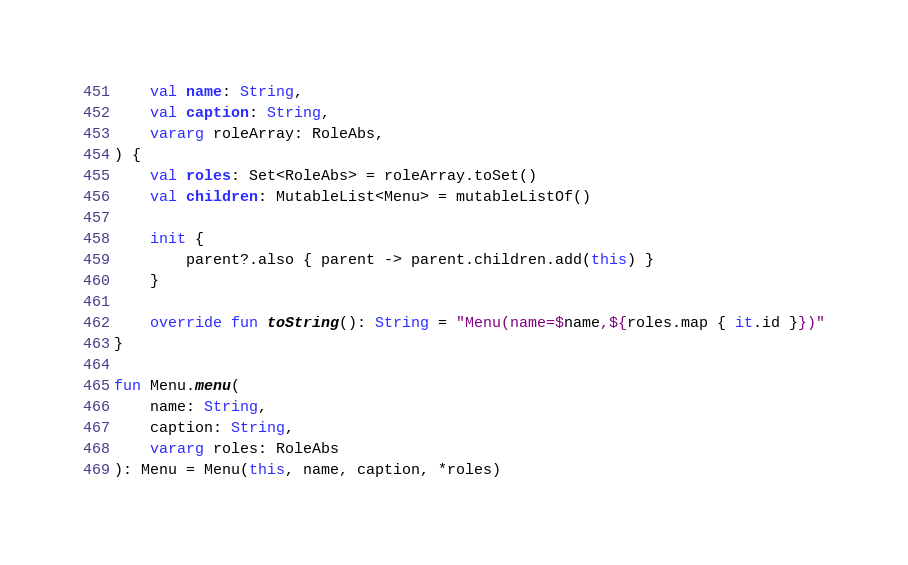<code> <loc_0><loc_0><loc_500><loc_500><_Kotlin_>    val name: String,
    val caption: String,
    vararg roleArray: RoleAbs,
) {
    val roles: Set<RoleAbs> = roleArray.toSet()
    val children: MutableList<Menu> = mutableListOf()

    init {
        parent?.also { parent -> parent.children.add(this) }
    }

    override fun toString(): String = "Menu(name=$name,${roles.map { it.id }})"
}

fun Menu.menu(
    name: String,
    caption: String,
    vararg roles: RoleAbs
): Menu = Menu(this, name, caption, *roles)

</code> 